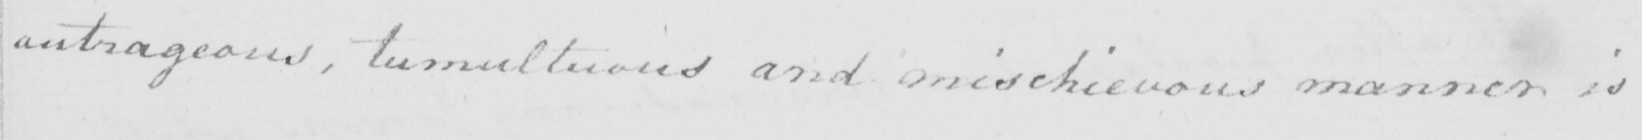What is written in this line of handwriting? outrageous , tumultuous and mischievous manner is 